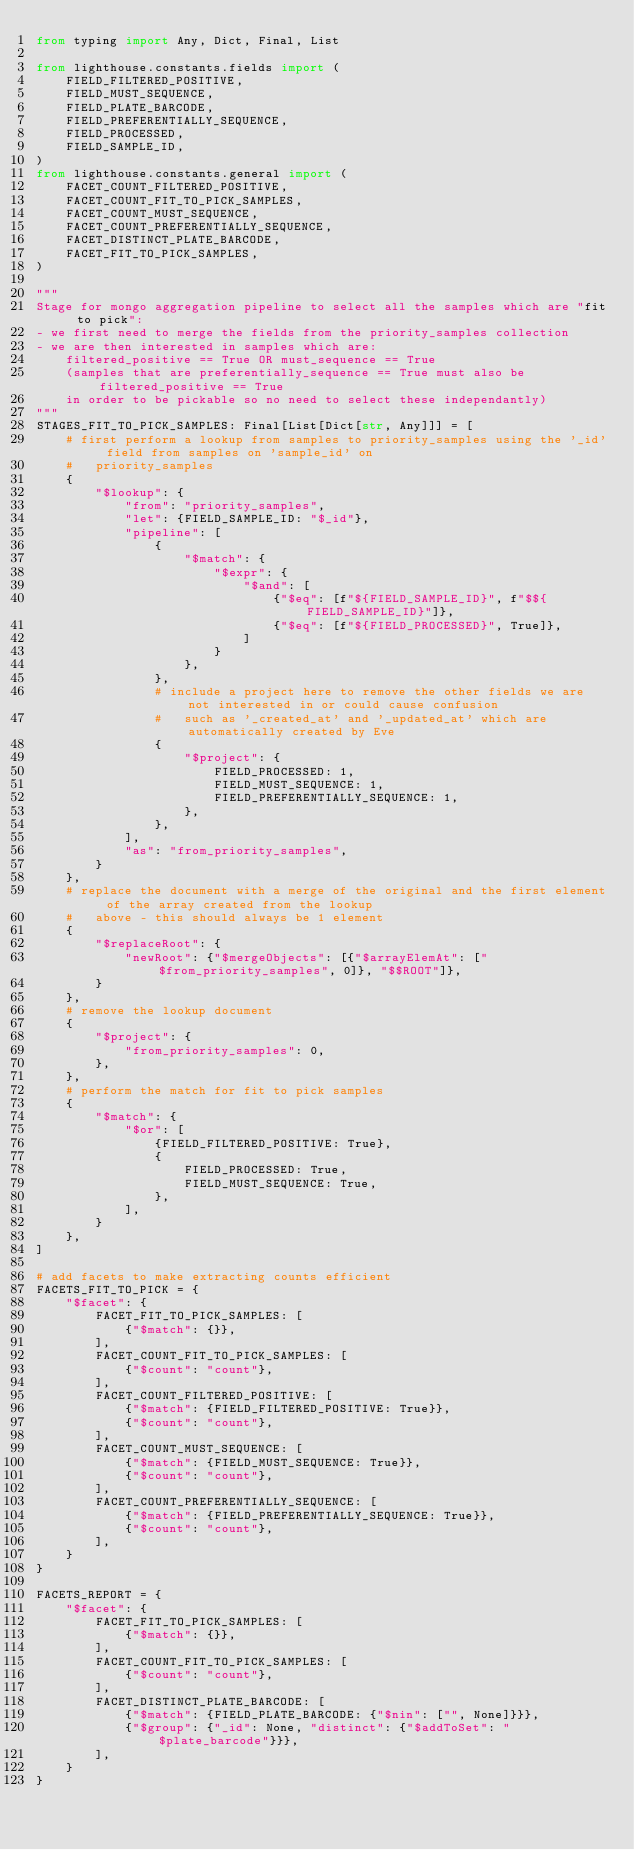Convert code to text. <code><loc_0><loc_0><loc_500><loc_500><_Python_>from typing import Any, Dict, Final, List

from lighthouse.constants.fields import (
    FIELD_FILTERED_POSITIVE,
    FIELD_MUST_SEQUENCE,
    FIELD_PLATE_BARCODE,
    FIELD_PREFERENTIALLY_SEQUENCE,
    FIELD_PROCESSED,
    FIELD_SAMPLE_ID,
)
from lighthouse.constants.general import (
    FACET_COUNT_FILTERED_POSITIVE,
    FACET_COUNT_FIT_TO_PICK_SAMPLES,
    FACET_COUNT_MUST_SEQUENCE,
    FACET_COUNT_PREFERENTIALLY_SEQUENCE,
    FACET_DISTINCT_PLATE_BARCODE,
    FACET_FIT_TO_PICK_SAMPLES,
)

"""
Stage for mongo aggregation pipeline to select all the samples which are "fit to pick":
- we first need to merge the fields from the priority_samples collection
- we are then interested in samples which are:
    filtered_positive == True OR must_sequence == True
    (samples that are preferentially_sequence == True must also be filtered_positive == True
    in order to be pickable so no need to select these independantly)
"""
STAGES_FIT_TO_PICK_SAMPLES: Final[List[Dict[str, Any]]] = [
    # first perform a lookup from samples to priority_samples using the '_id' field from samples on 'sample_id' on
    #   priority_samples
    {
        "$lookup": {
            "from": "priority_samples",
            "let": {FIELD_SAMPLE_ID: "$_id"},
            "pipeline": [
                {
                    "$match": {
                        "$expr": {
                            "$and": [
                                {"$eq": [f"${FIELD_SAMPLE_ID}", f"$${FIELD_SAMPLE_ID}"]},
                                {"$eq": [f"${FIELD_PROCESSED}", True]},
                            ]
                        }
                    },
                },
                # include a project here to remove the other fields we are not interested in or could cause confusion
                #   such as '_created_at' and '_updated_at' which are automatically created by Eve
                {
                    "$project": {
                        FIELD_PROCESSED: 1,
                        FIELD_MUST_SEQUENCE: 1,
                        FIELD_PREFERENTIALLY_SEQUENCE: 1,
                    },
                },
            ],
            "as": "from_priority_samples",
        }
    },
    # replace the document with a merge of the original and the first element of the array created from the lookup
    #   above - this should always be 1 element
    {
        "$replaceRoot": {
            "newRoot": {"$mergeObjects": [{"$arrayElemAt": ["$from_priority_samples", 0]}, "$$ROOT"]},
        }
    },
    # remove the lookup document
    {
        "$project": {
            "from_priority_samples": 0,
        },
    },
    # perform the match for fit to pick samples
    {
        "$match": {
            "$or": [
                {FIELD_FILTERED_POSITIVE: True},
                {
                    FIELD_PROCESSED: True,
                    FIELD_MUST_SEQUENCE: True,
                },
            ],
        }
    },
]

# add facets to make extracting counts efficient
FACETS_FIT_TO_PICK = {
    "$facet": {
        FACET_FIT_TO_PICK_SAMPLES: [
            {"$match": {}},
        ],
        FACET_COUNT_FIT_TO_PICK_SAMPLES: [
            {"$count": "count"},
        ],
        FACET_COUNT_FILTERED_POSITIVE: [
            {"$match": {FIELD_FILTERED_POSITIVE: True}},
            {"$count": "count"},
        ],
        FACET_COUNT_MUST_SEQUENCE: [
            {"$match": {FIELD_MUST_SEQUENCE: True}},
            {"$count": "count"},
        ],
        FACET_COUNT_PREFERENTIALLY_SEQUENCE: [
            {"$match": {FIELD_PREFERENTIALLY_SEQUENCE: True}},
            {"$count": "count"},
        ],
    }
}

FACETS_REPORT = {
    "$facet": {
        FACET_FIT_TO_PICK_SAMPLES: [
            {"$match": {}},
        ],
        FACET_COUNT_FIT_TO_PICK_SAMPLES: [
            {"$count": "count"},
        ],
        FACET_DISTINCT_PLATE_BARCODE: [
            {"$match": {FIELD_PLATE_BARCODE: {"$nin": ["", None]}}},
            {"$group": {"_id": None, "distinct": {"$addToSet": "$plate_barcode"}}},
        ],
    }
}
</code> 